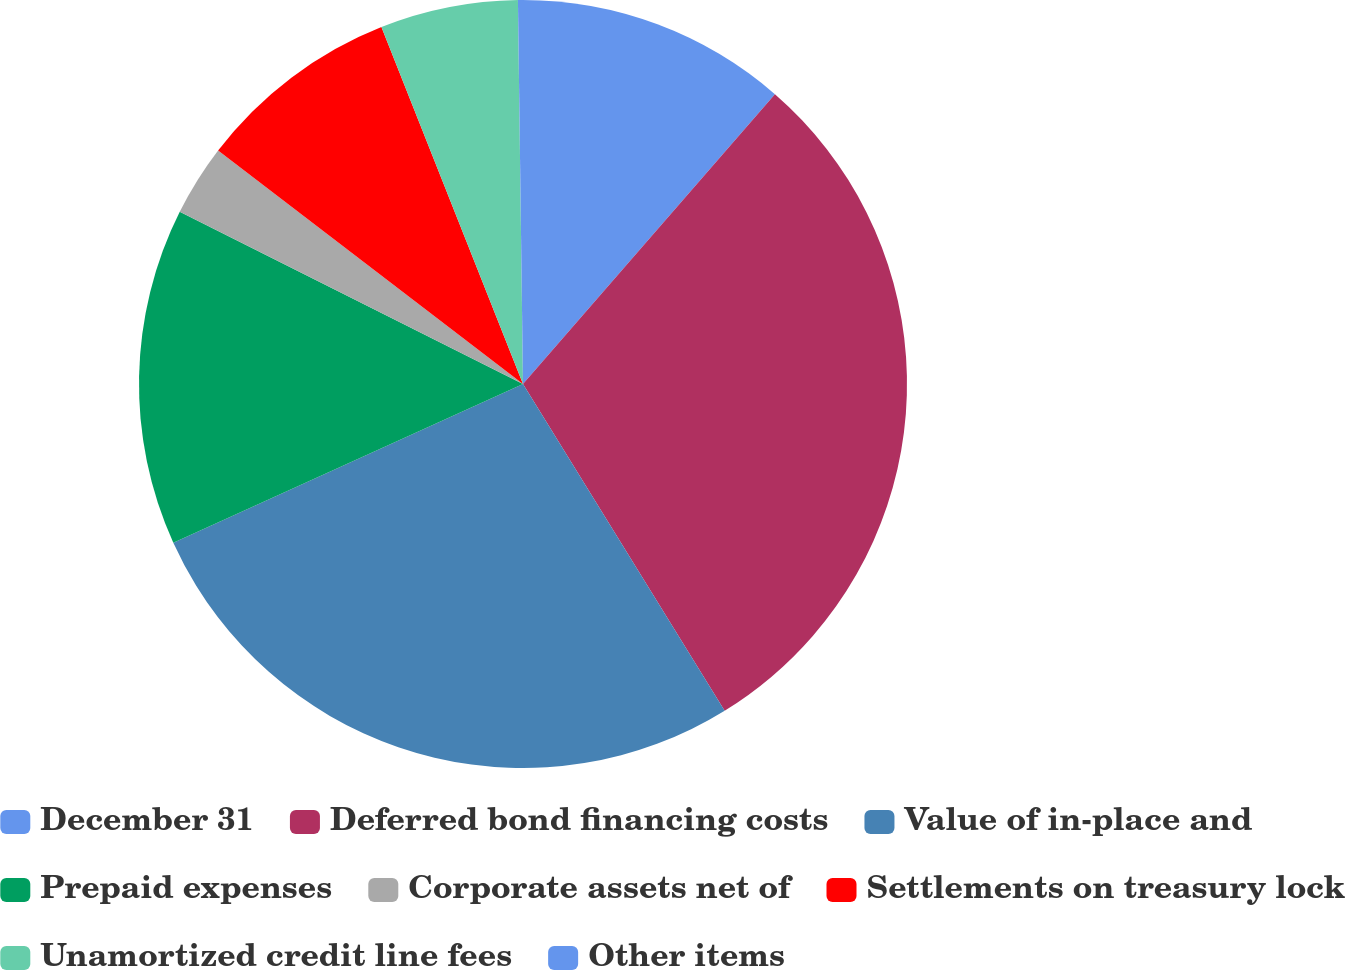Convert chart. <chart><loc_0><loc_0><loc_500><loc_500><pie_chart><fcel>December 31<fcel>Deferred bond financing costs<fcel>Value of in-place and<fcel>Prepaid expenses<fcel>Corporate assets net of<fcel>Settlements on treasury lock<fcel>Unamortized credit line fees<fcel>Other items<nl><fcel>11.39%<fcel>29.81%<fcel>27.02%<fcel>14.18%<fcel>3.0%<fcel>8.59%<fcel>5.8%<fcel>0.21%<nl></chart> 